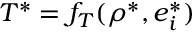<formula> <loc_0><loc_0><loc_500><loc_500>T ^ { * } = f _ { T } ( \rho ^ { * } , e _ { i } ^ { * } )</formula> 